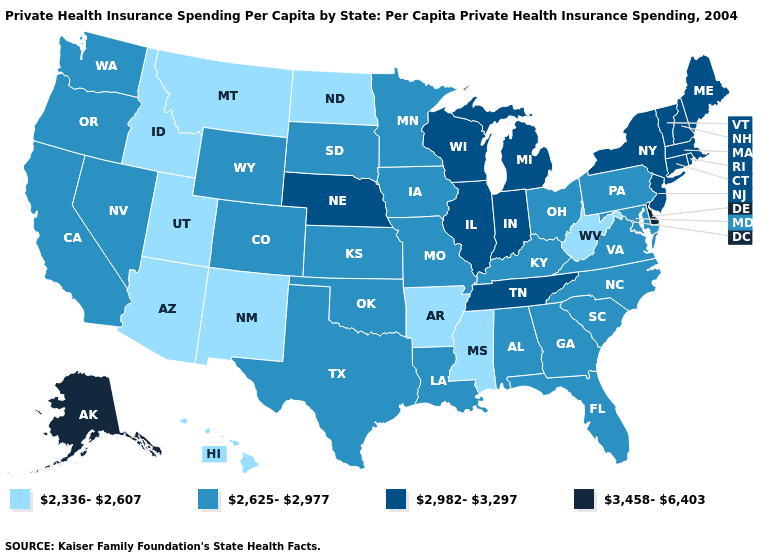Name the states that have a value in the range 3,458-6,403?
Keep it brief. Alaska, Delaware. What is the value of Washington?
Answer briefly. 2,625-2,977. What is the highest value in the Northeast ?
Concise answer only. 2,982-3,297. What is the highest value in states that border Alabama?
Answer briefly. 2,982-3,297. What is the value of Pennsylvania?
Give a very brief answer. 2,625-2,977. Does Alaska have the highest value in the USA?
Write a very short answer. Yes. Among the states that border Oklahoma , does New Mexico have the highest value?
Write a very short answer. No. Among the states that border Louisiana , does Texas have the highest value?
Answer briefly. Yes. What is the lowest value in the USA?
Answer briefly. 2,336-2,607. Does Massachusetts have a higher value than Arizona?
Quick response, please. Yes. What is the lowest value in the USA?
Short answer required. 2,336-2,607. What is the value of Montana?
Give a very brief answer. 2,336-2,607. Which states have the lowest value in the USA?
Write a very short answer. Arizona, Arkansas, Hawaii, Idaho, Mississippi, Montana, New Mexico, North Dakota, Utah, West Virginia. Name the states that have a value in the range 2,336-2,607?
Quick response, please. Arizona, Arkansas, Hawaii, Idaho, Mississippi, Montana, New Mexico, North Dakota, Utah, West Virginia. 